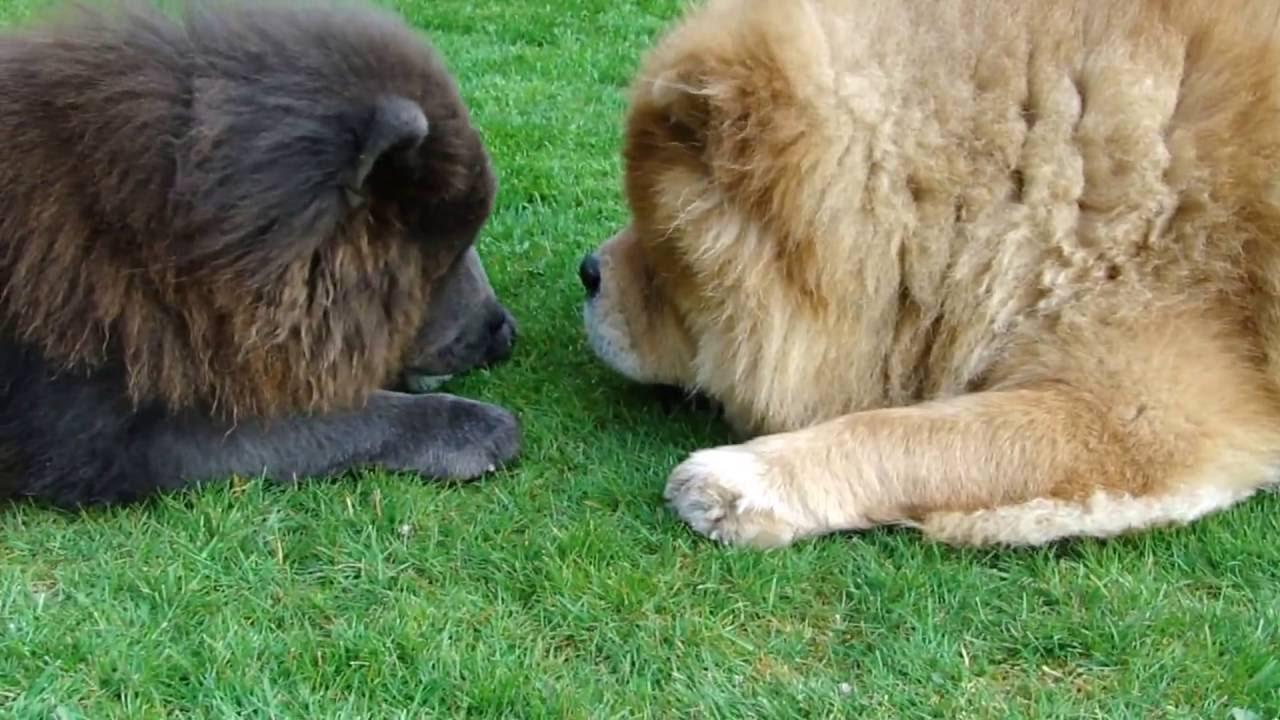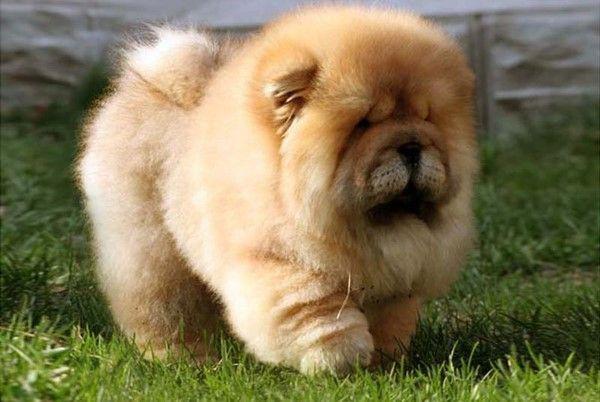The first image is the image on the left, the second image is the image on the right. Examine the images to the left and right. Is the description "One of the images shows only one dog." accurate? Answer yes or no. Yes. The first image is the image on the left, the second image is the image on the right. Considering the images on both sides, is "One dog in the image on the left is jumping up onto another dog." valid? Answer yes or no. No. 